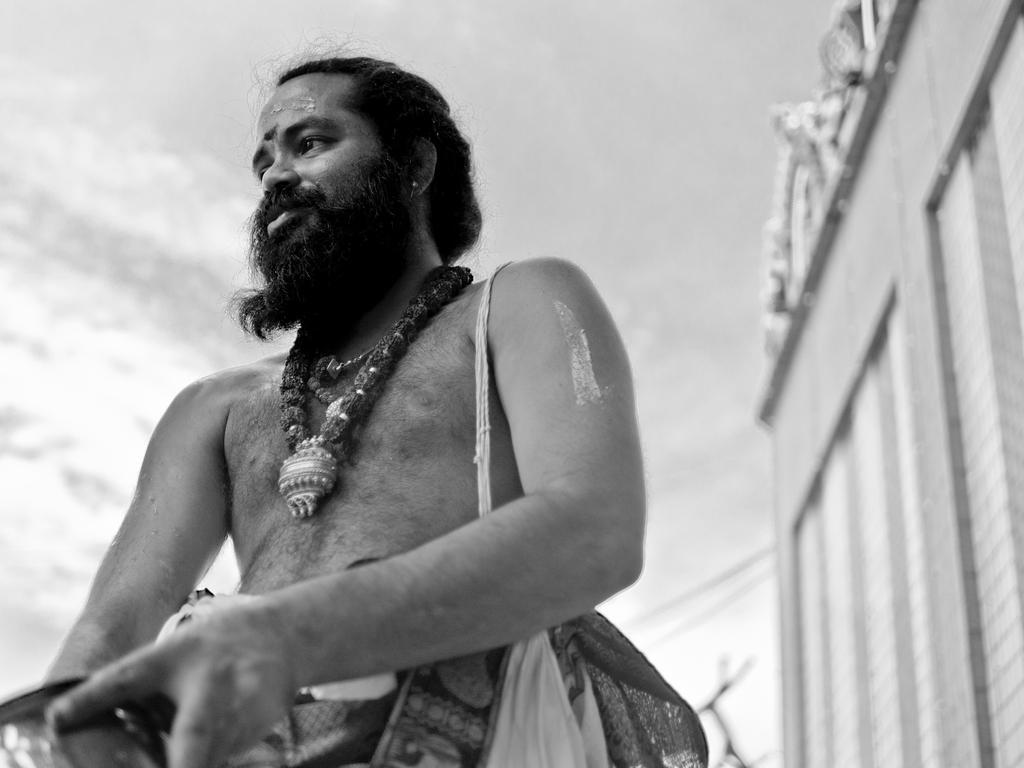Describe this image in one or two sentences. In this picture we can see a man carrying a bag and in the background we can see wall. 